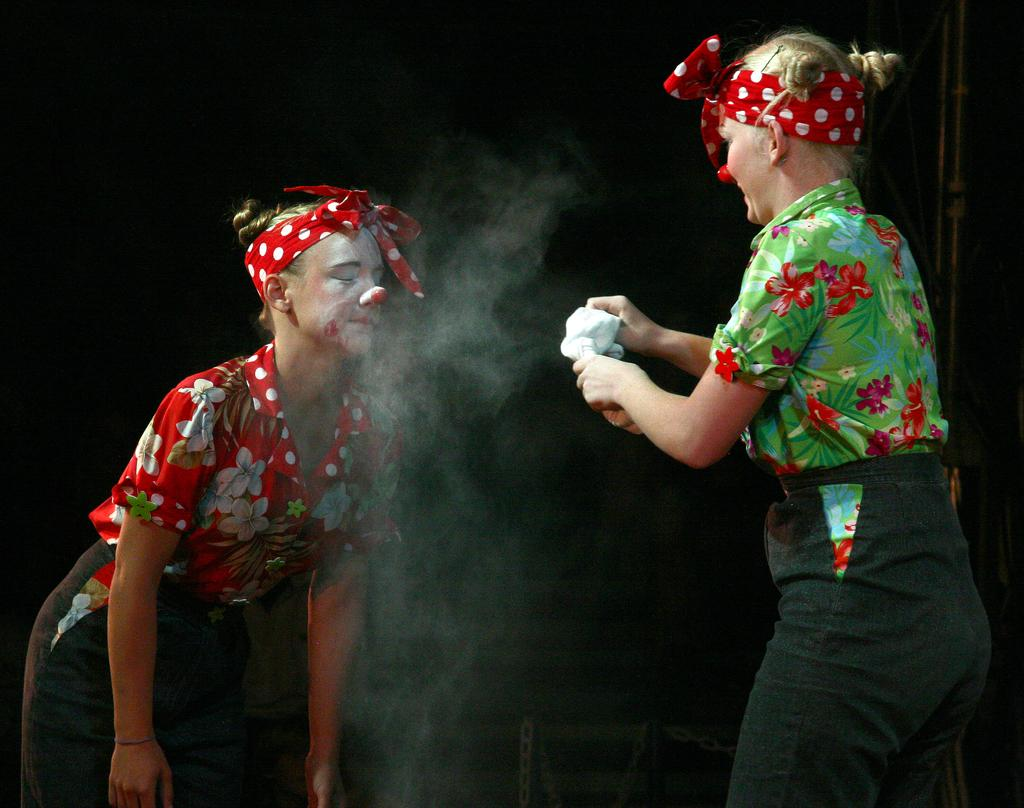How many people are in the image? There are two persons in the image. What are the persons doing in the image? The persons are standing. What are the persons wearing in the image? The persons are wearing clothes. What is the color of the background in the image? The background of the image is black. Can you see a toad jumping in the image? There is no toad present in the image. Are the persons stretching their arms in the image? The provided facts do not mention anything about the persons stretching their arms. 